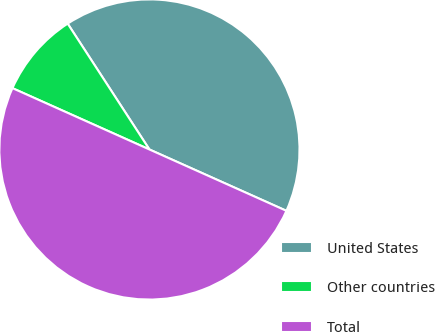<chart> <loc_0><loc_0><loc_500><loc_500><pie_chart><fcel>United States<fcel>Other countries<fcel>Total<nl><fcel>40.87%<fcel>9.13%<fcel>50.0%<nl></chart> 